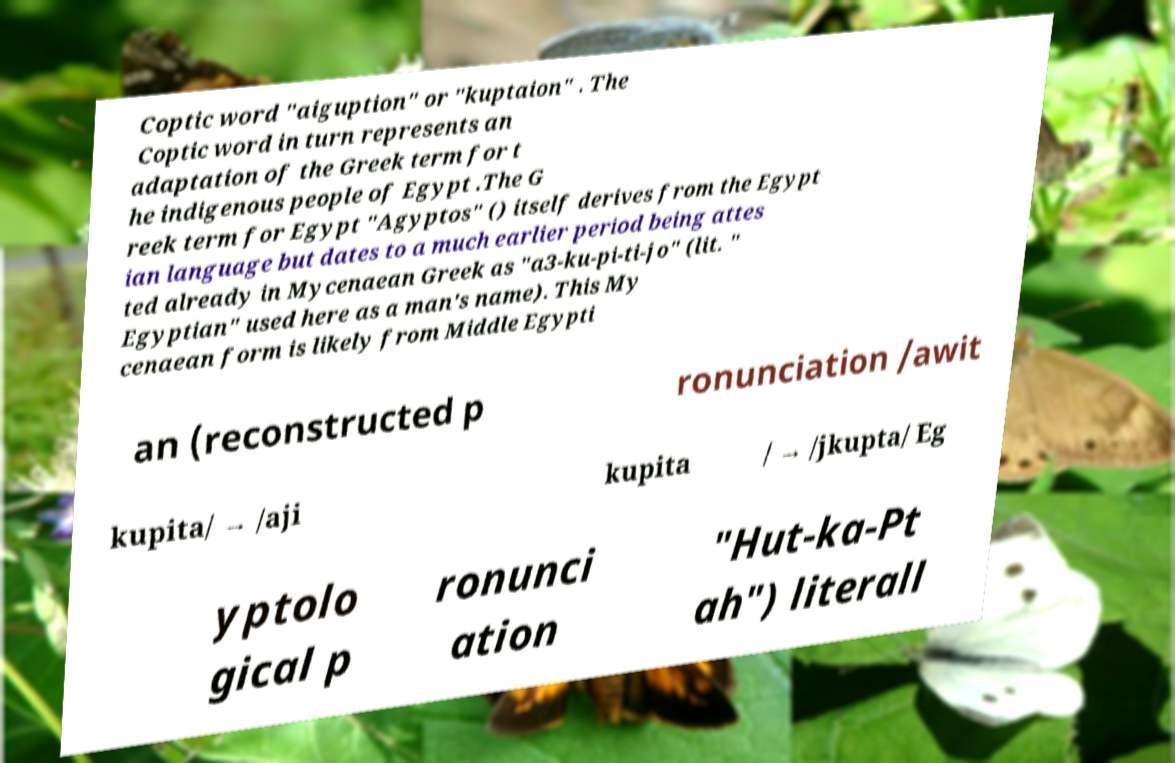Please identify and transcribe the text found in this image. Coptic word "aiguption" or "kuptaion" . The Coptic word in turn represents an adaptation of the Greek term for t he indigenous people of Egypt .The G reek term for Egypt "Agyptos" () itself derives from the Egypt ian language but dates to a much earlier period being attes ted already in Mycenaean Greek as "a3-ku-pi-ti-jo" (lit. " Egyptian" used here as a man's name). This My cenaean form is likely from Middle Egypti an (reconstructed p ronunciation /awit kupita/ → /aji kupita / → /jkupta/ Eg yptolo gical p ronunci ation "Hut-ka-Pt ah") literall 